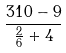<formula> <loc_0><loc_0><loc_500><loc_500>\frac { 3 1 0 - 9 } { \frac { 2 } { 6 } + 4 }</formula> 